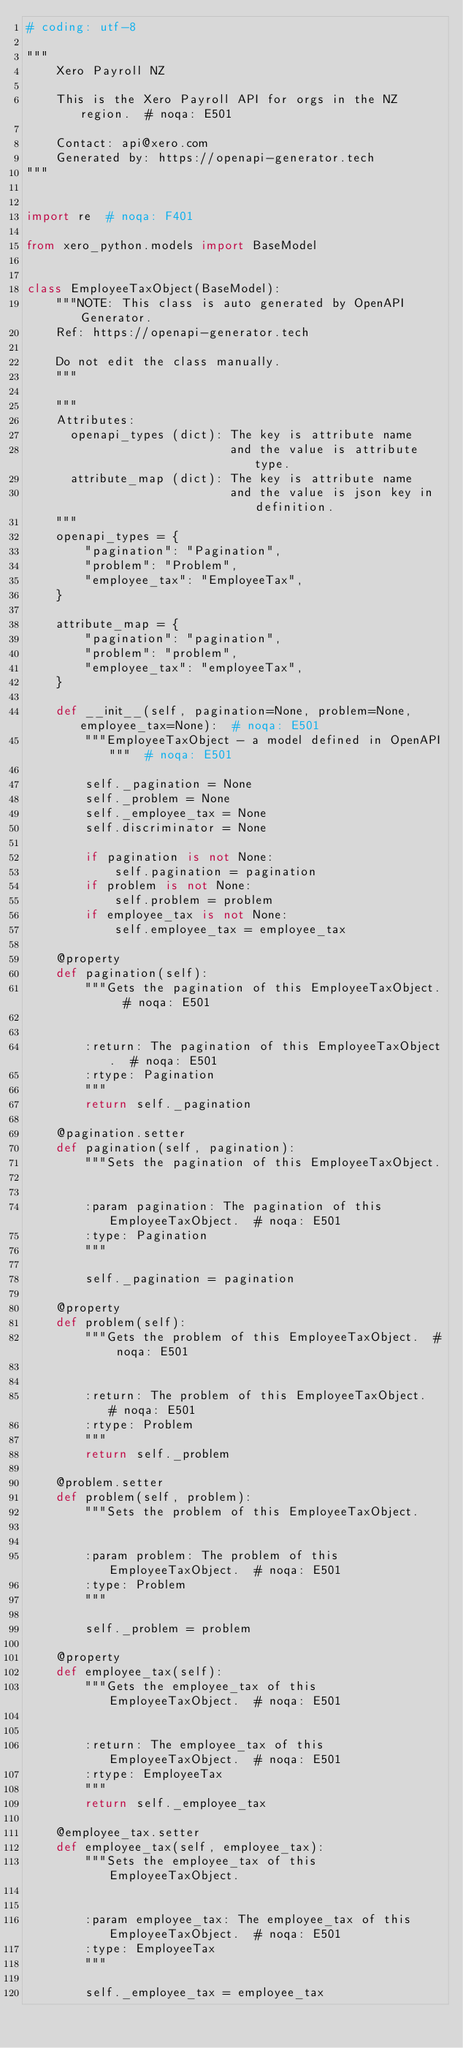<code> <loc_0><loc_0><loc_500><loc_500><_Python_># coding: utf-8

"""
    Xero Payroll NZ

    This is the Xero Payroll API for orgs in the NZ region.  # noqa: E501

    Contact: api@xero.com
    Generated by: https://openapi-generator.tech
"""


import re  # noqa: F401

from xero_python.models import BaseModel


class EmployeeTaxObject(BaseModel):
    """NOTE: This class is auto generated by OpenAPI Generator.
    Ref: https://openapi-generator.tech

    Do not edit the class manually.
    """

    """
    Attributes:
      openapi_types (dict): The key is attribute name
                            and the value is attribute type.
      attribute_map (dict): The key is attribute name
                            and the value is json key in definition.
    """
    openapi_types = {
        "pagination": "Pagination",
        "problem": "Problem",
        "employee_tax": "EmployeeTax",
    }

    attribute_map = {
        "pagination": "pagination",
        "problem": "problem",
        "employee_tax": "employeeTax",
    }

    def __init__(self, pagination=None, problem=None, employee_tax=None):  # noqa: E501
        """EmployeeTaxObject - a model defined in OpenAPI"""  # noqa: E501

        self._pagination = None
        self._problem = None
        self._employee_tax = None
        self.discriminator = None

        if pagination is not None:
            self.pagination = pagination
        if problem is not None:
            self.problem = problem
        if employee_tax is not None:
            self.employee_tax = employee_tax

    @property
    def pagination(self):
        """Gets the pagination of this EmployeeTaxObject.  # noqa: E501


        :return: The pagination of this EmployeeTaxObject.  # noqa: E501
        :rtype: Pagination
        """
        return self._pagination

    @pagination.setter
    def pagination(self, pagination):
        """Sets the pagination of this EmployeeTaxObject.


        :param pagination: The pagination of this EmployeeTaxObject.  # noqa: E501
        :type: Pagination
        """

        self._pagination = pagination

    @property
    def problem(self):
        """Gets the problem of this EmployeeTaxObject.  # noqa: E501


        :return: The problem of this EmployeeTaxObject.  # noqa: E501
        :rtype: Problem
        """
        return self._problem

    @problem.setter
    def problem(self, problem):
        """Sets the problem of this EmployeeTaxObject.


        :param problem: The problem of this EmployeeTaxObject.  # noqa: E501
        :type: Problem
        """

        self._problem = problem

    @property
    def employee_tax(self):
        """Gets the employee_tax of this EmployeeTaxObject.  # noqa: E501


        :return: The employee_tax of this EmployeeTaxObject.  # noqa: E501
        :rtype: EmployeeTax
        """
        return self._employee_tax

    @employee_tax.setter
    def employee_tax(self, employee_tax):
        """Sets the employee_tax of this EmployeeTaxObject.


        :param employee_tax: The employee_tax of this EmployeeTaxObject.  # noqa: E501
        :type: EmployeeTax
        """

        self._employee_tax = employee_tax
</code> 